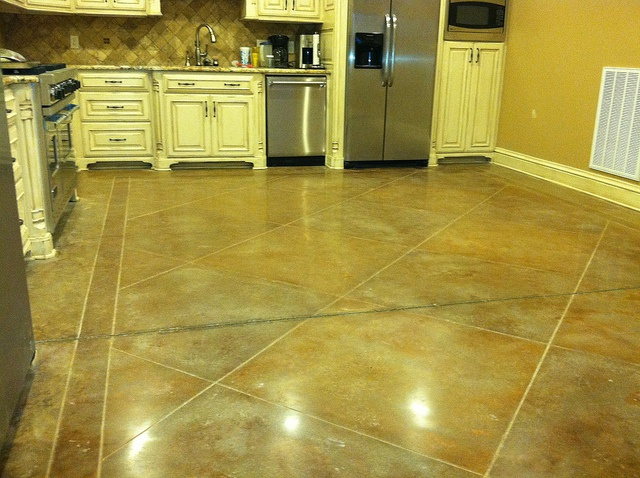Describe the objects in this image and their specific colors. I can see refrigerator in olive and black tones, oven in olive and black tones, microwave in olive and black tones, sink in olive and khaki tones, and cup in olive, khaki, beige, and darkgray tones in this image. 